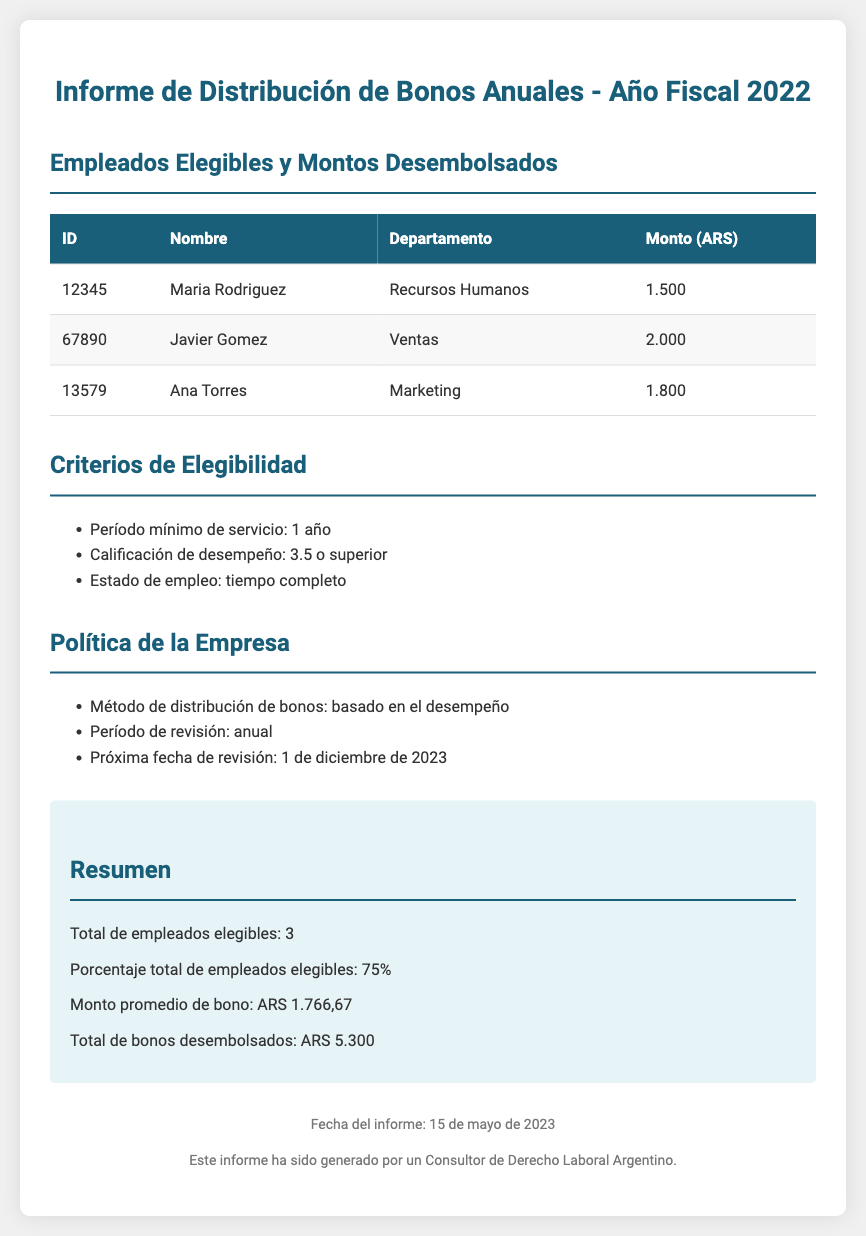what is the title of the document? The title is displayed prominently at the top of the document, indicating the subject matter.
Answer: Informe de Distribución de Bonos Anuales - Año Fiscal 2022 how many employees are eligible for the bonus? The summary section of the document provides this information clearly.
Answer: 3 what is the average bonus amount distributed? The average amount is calculated and presented in the summary section of the document.
Answer: ARS 1.766,67 who received the highest bonus amount? By comparing the amounts listed in the table, you can identify the individual with the highest disbursal.
Answer: Javier Gomez what are the eligibility criteria for the bonus? The document lists these criteria in a bulleted format under a specific heading.
Answer: Período mínimo de servicio: 1 año; Calificación de desempeño: 3.5 o superior; Estado de empleo: tiempo completo when was the report generated? The footer of the document includes the date when the report was created.
Answer: 15 de mayo de 2023 what is the total amount of bonuses disbursed? The total is summarized in the document, consolidating the amounts given to all eligible employees.
Answer: ARS 5.300 when is the next review date for bonus distribution? This information is specifically mentioned in the policy section of the document regarding future reviews.
Answer: 1 de diciembre de 2023 